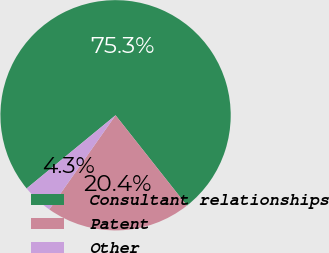Convert chart to OTSL. <chart><loc_0><loc_0><loc_500><loc_500><pie_chart><fcel>Consultant relationships<fcel>Patent<fcel>Other<nl><fcel>75.31%<fcel>20.4%<fcel>4.28%<nl></chart> 